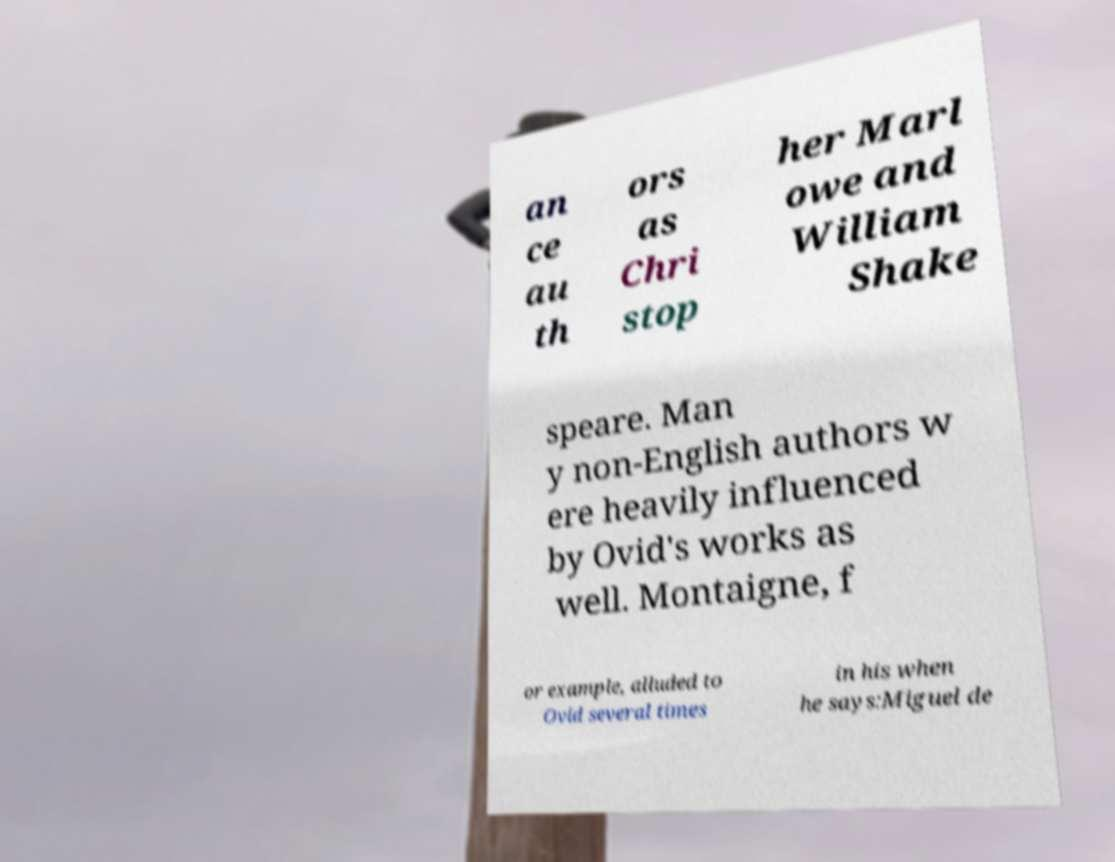Could you extract and type out the text from this image? an ce au th ors as Chri stop her Marl owe and William Shake speare. Man y non-English authors w ere heavily influenced by Ovid's works as well. Montaigne, f or example, alluded to Ovid several times in his when he says:Miguel de 